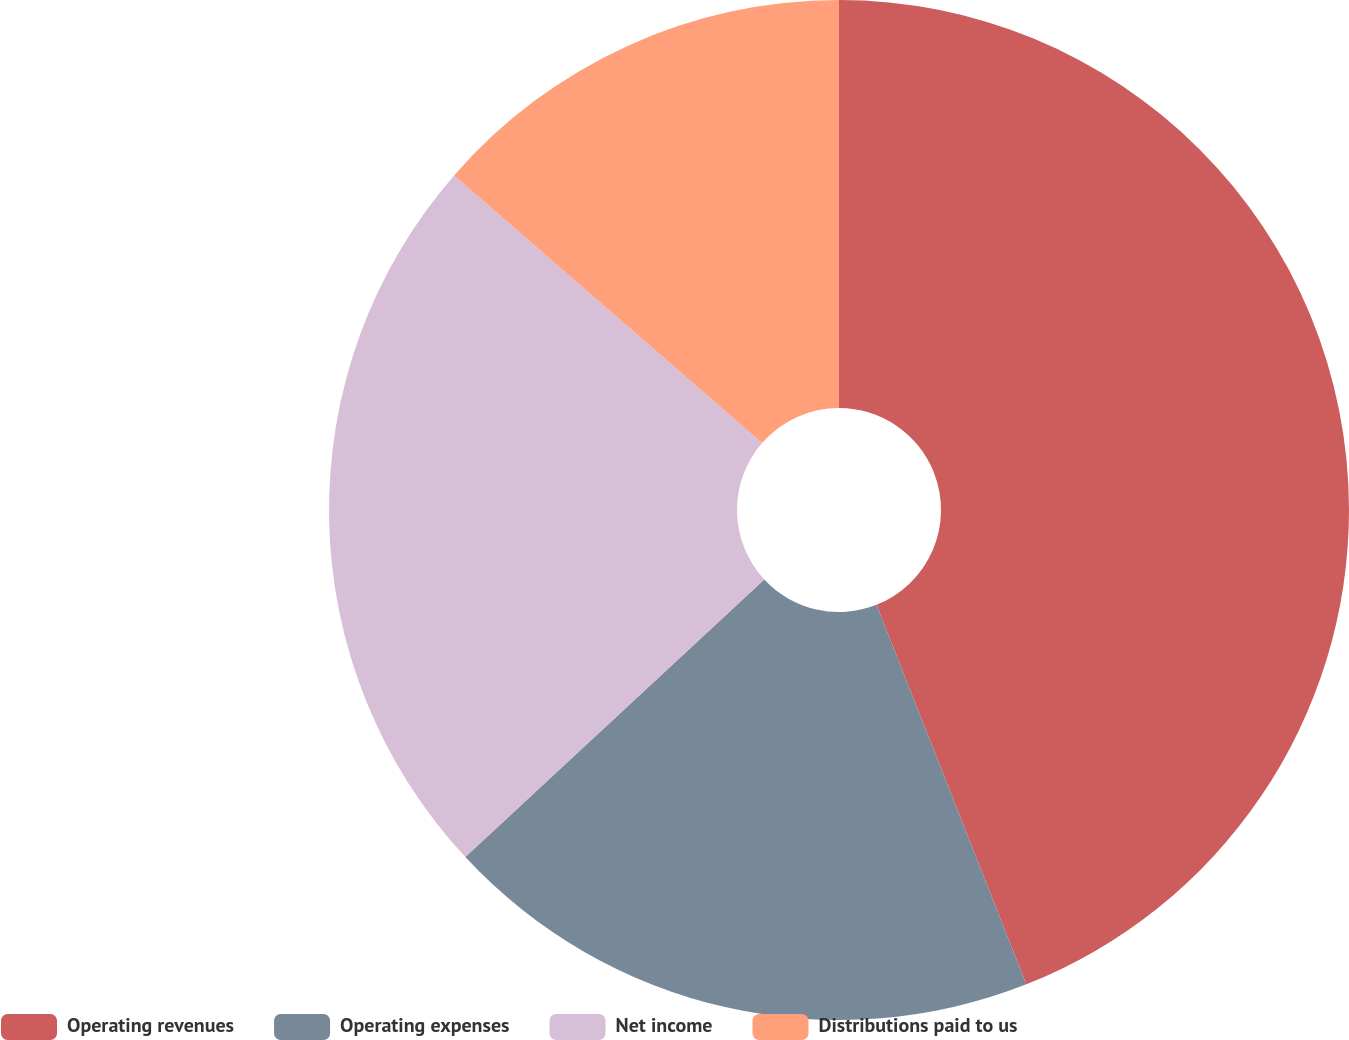<chart> <loc_0><loc_0><loc_500><loc_500><pie_chart><fcel>Operating revenues<fcel>Operating expenses<fcel>Net income<fcel>Distributions paid to us<nl><fcel>44.01%<fcel>19.07%<fcel>23.3%<fcel>13.61%<nl></chart> 